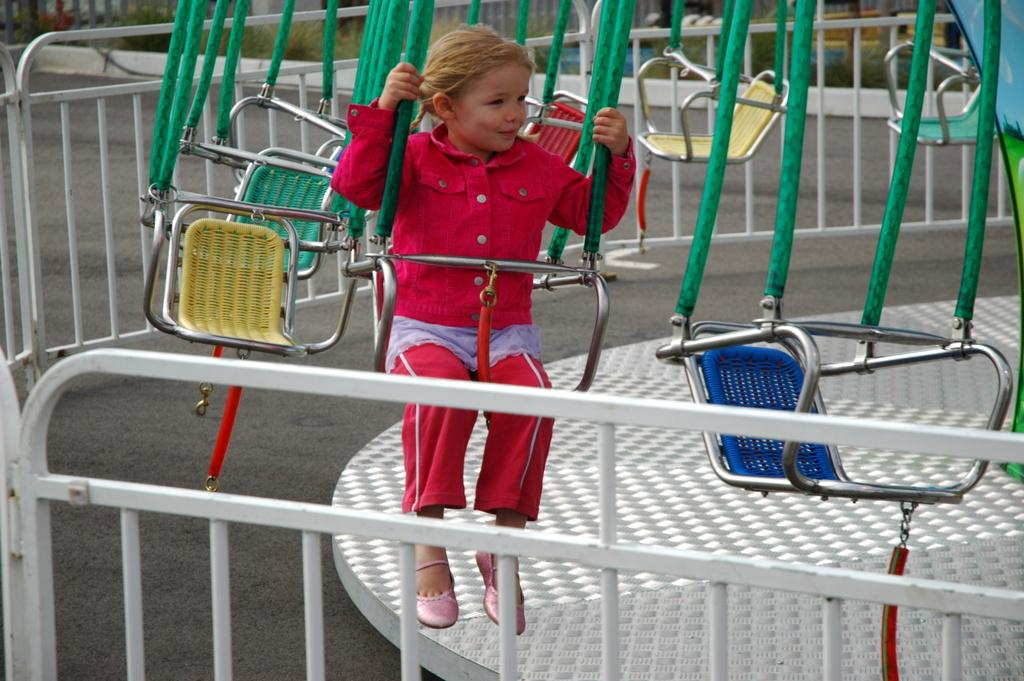What is the child doing in the image? The child is sitting on a chair in the image. What activity is the child likely engaged in? It appears to be a game in the image. What type of vegetation can be seen in the image? There are plants visible in the image. What architectural feature is present in the image? There is a railing in the image. What type of beetle can be seen crawling on the edge of the game in the image? There is no beetle present in the image, and the edge of the game cannot be determined from the provided facts. 